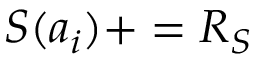<formula> <loc_0><loc_0><loc_500><loc_500>S ( a _ { i } ) + = R _ { S }</formula> 